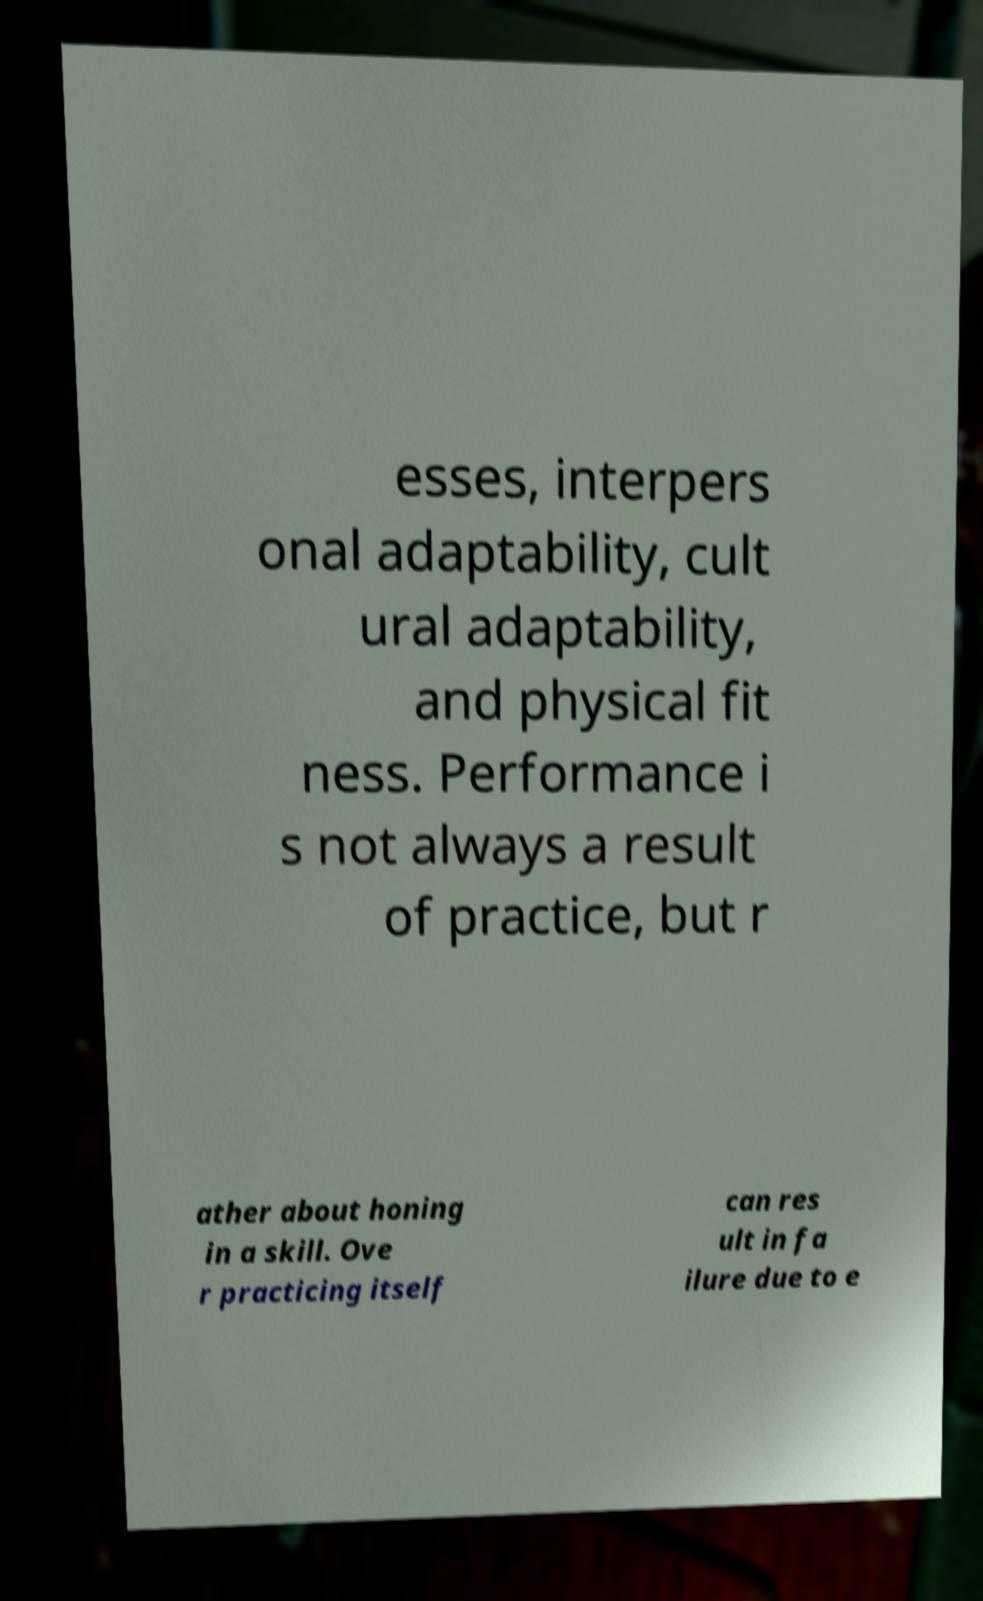For documentation purposes, I need the text within this image transcribed. Could you provide that? esses, interpers onal adaptability, cult ural adaptability, and physical fit ness. Performance i s not always a result of practice, but r ather about honing in a skill. Ove r practicing itself can res ult in fa ilure due to e 